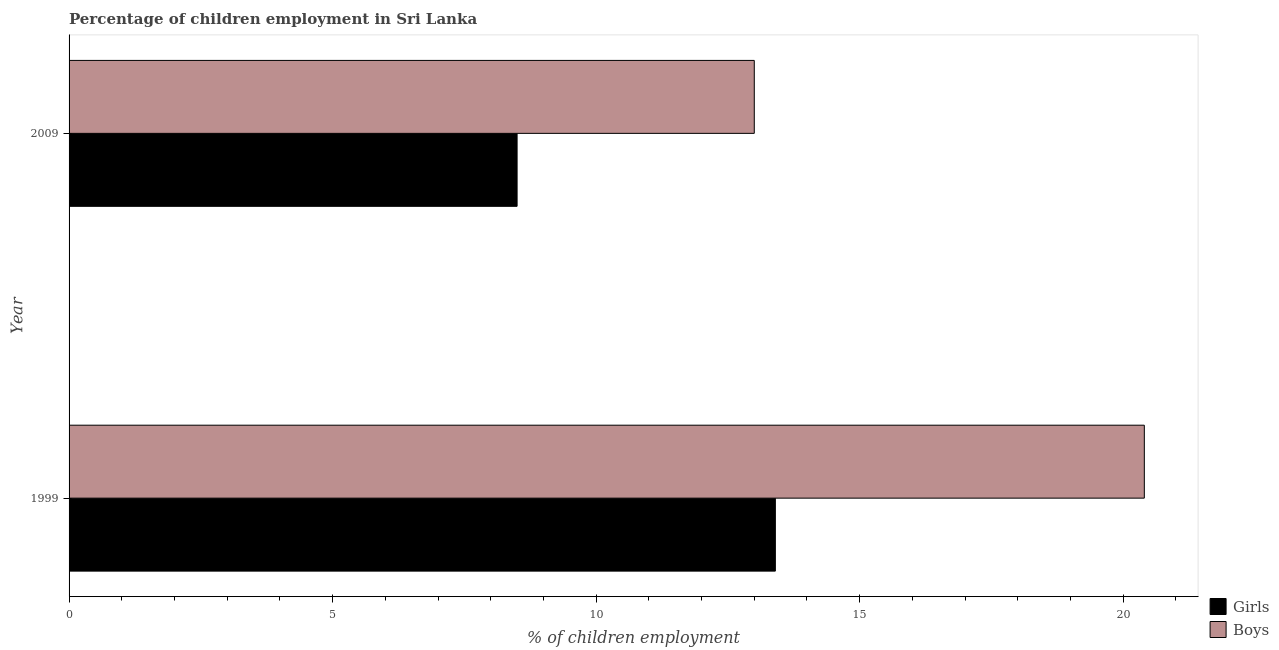Are the number of bars per tick equal to the number of legend labels?
Offer a very short reply. Yes. How many bars are there on the 2nd tick from the bottom?
Offer a very short reply. 2. What is the label of the 2nd group of bars from the top?
Ensure brevity in your answer.  1999. In how many cases, is the number of bars for a given year not equal to the number of legend labels?
Offer a terse response. 0. What is the percentage of employed boys in 1999?
Give a very brief answer. 20.4. Across all years, what is the minimum percentage of employed girls?
Offer a very short reply. 8.5. What is the total percentage of employed girls in the graph?
Keep it short and to the point. 21.9. What is the difference between the percentage of employed girls in 2009 and the percentage of employed boys in 1999?
Offer a very short reply. -11.9. In the year 2009, what is the difference between the percentage of employed boys and percentage of employed girls?
Your answer should be compact. 4.5. What is the ratio of the percentage of employed girls in 1999 to that in 2009?
Provide a succinct answer. 1.58. Is the percentage of employed boys in 1999 less than that in 2009?
Offer a terse response. No. What does the 1st bar from the top in 1999 represents?
Offer a very short reply. Boys. What does the 2nd bar from the bottom in 1999 represents?
Your answer should be compact. Boys. How many bars are there?
Keep it short and to the point. 4. How many years are there in the graph?
Make the answer very short. 2. What is the difference between two consecutive major ticks on the X-axis?
Offer a very short reply. 5. Where does the legend appear in the graph?
Ensure brevity in your answer.  Bottom right. How many legend labels are there?
Provide a succinct answer. 2. What is the title of the graph?
Provide a succinct answer. Percentage of children employment in Sri Lanka. What is the label or title of the X-axis?
Provide a short and direct response. % of children employment. What is the % of children employment of Girls in 1999?
Your response must be concise. 13.4. What is the % of children employment of Boys in 1999?
Ensure brevity in your answer.  20.4. What is the % of children employment of Girls in 2009?
Offer a very short reply. 8.5. What is the % of children employment of Boys in 2009?
Give a very brief answer. 13. Across all years, what is the maximum % of children employment of Boys?
Provide a short and direct response. 20.4. Across all years, what is the minimum % of children employment of Girls?
Your response must be concise. 8.5. Across all years, what is the minimum % of children employment in Boys?
Your answer should be compact. 13. What is the total % of children employment of Girls in the graph?
Give a very brief answer. 21.9. What is the total % of children employment in Boys in the graph?
Offer a terse response. 33.4. What is the difference between the % of children employment of Girls in 1999 and that in 2009?
Provide a succinct answer. 4.9. What is the average % of children employment in Girls per year?
Offer a terse response. 10.95. What is the average % of children employment of Boys per year?
Keep it short and to the point. 16.7. In the year 2009, what is the difference between the % of children employment of Girls and % of children employment of Boys?
Your response must be concise. -4.5. What is the ratio of the % of children employment of Girls in 1999 to that in 2009?
Provide a succinct answer. 1.58. What is the ratio of the % of children employment in Boys in 1999 to that in 2009?
Your answer should be very brief. 1.57. What is the difference between the highest and the lowest % of children employment in Boys?
Offer a terse response. 7.4. 